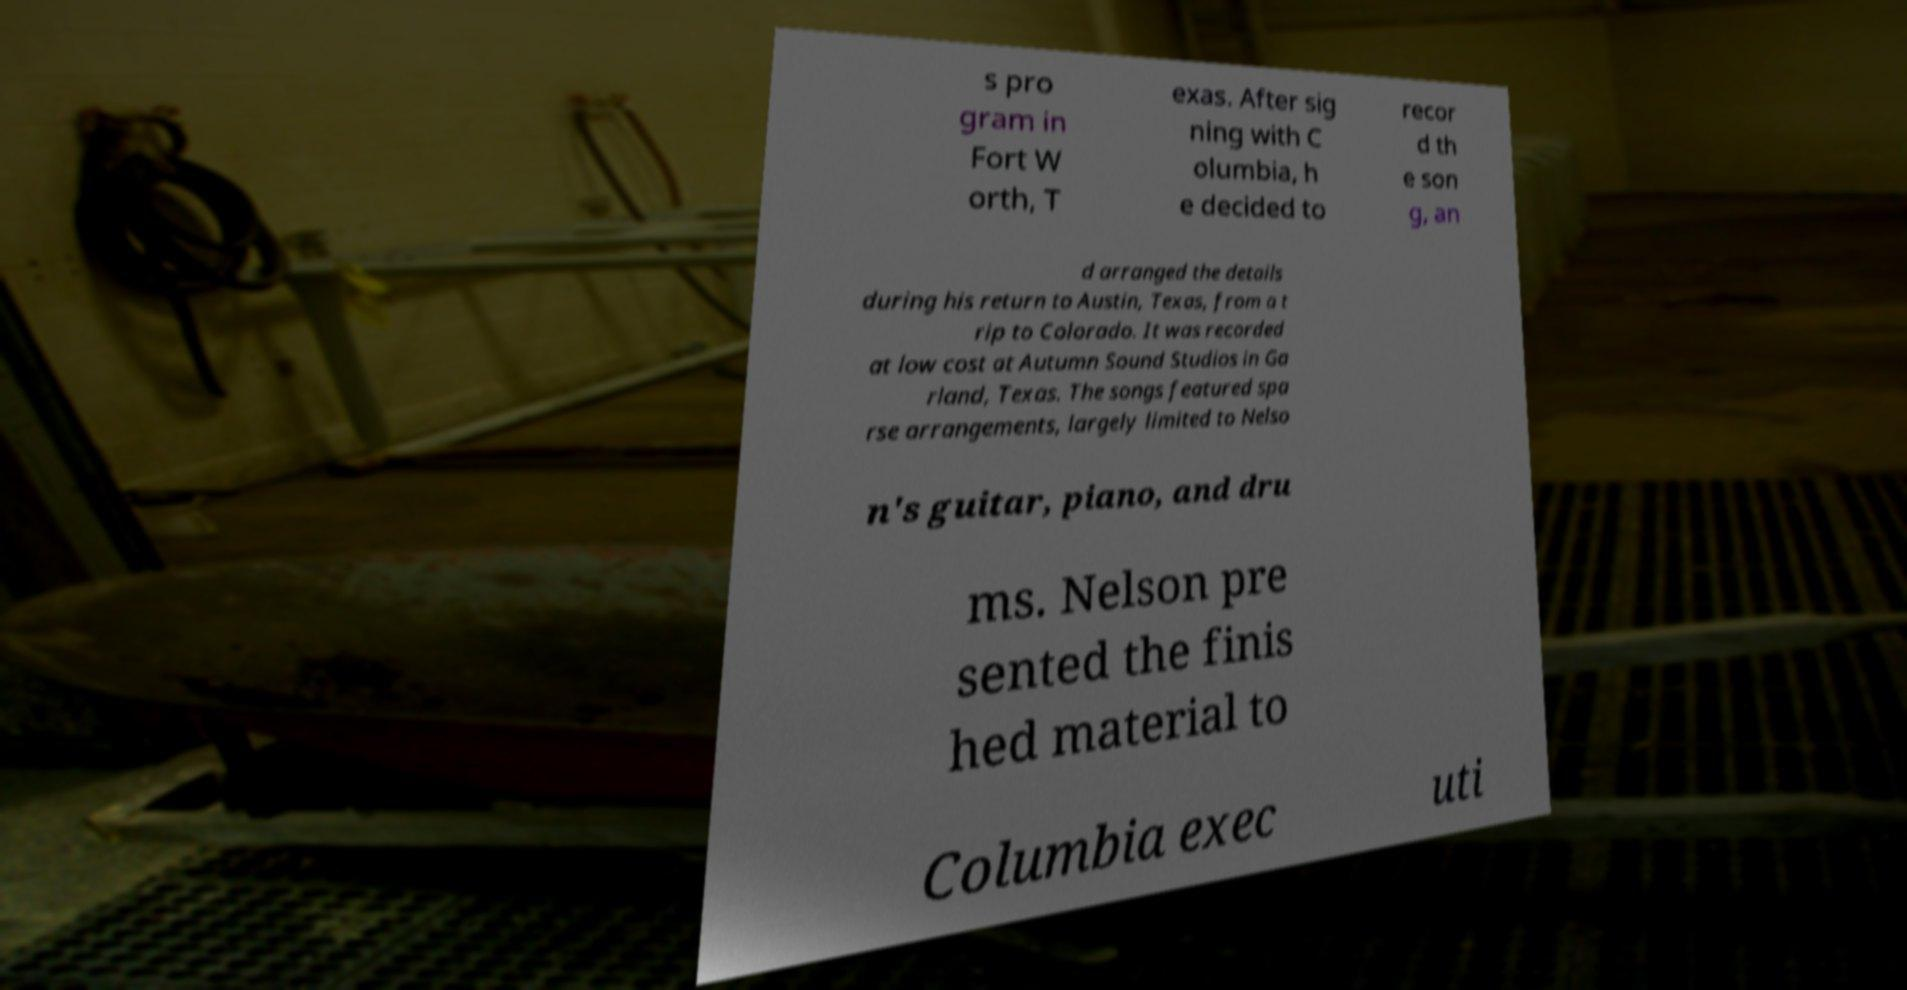Can you accurately transcribe the text from the provided image for me? s pro gram in Fort W orth, T exas. After sig ning with C olumbia, h e decided to recor d th e son g, an d arranged the details during his return to Austin, Texas, from a t rip to Colorado. It was recorded at low cost at Autumn Sound Studios in Ga rland, Texas. The songs featured spa rse arrangements, largely limited to Nelso n's guitar, piano, and dru ms. Nelson pre sented the finis hed material to Columbia exec uti 